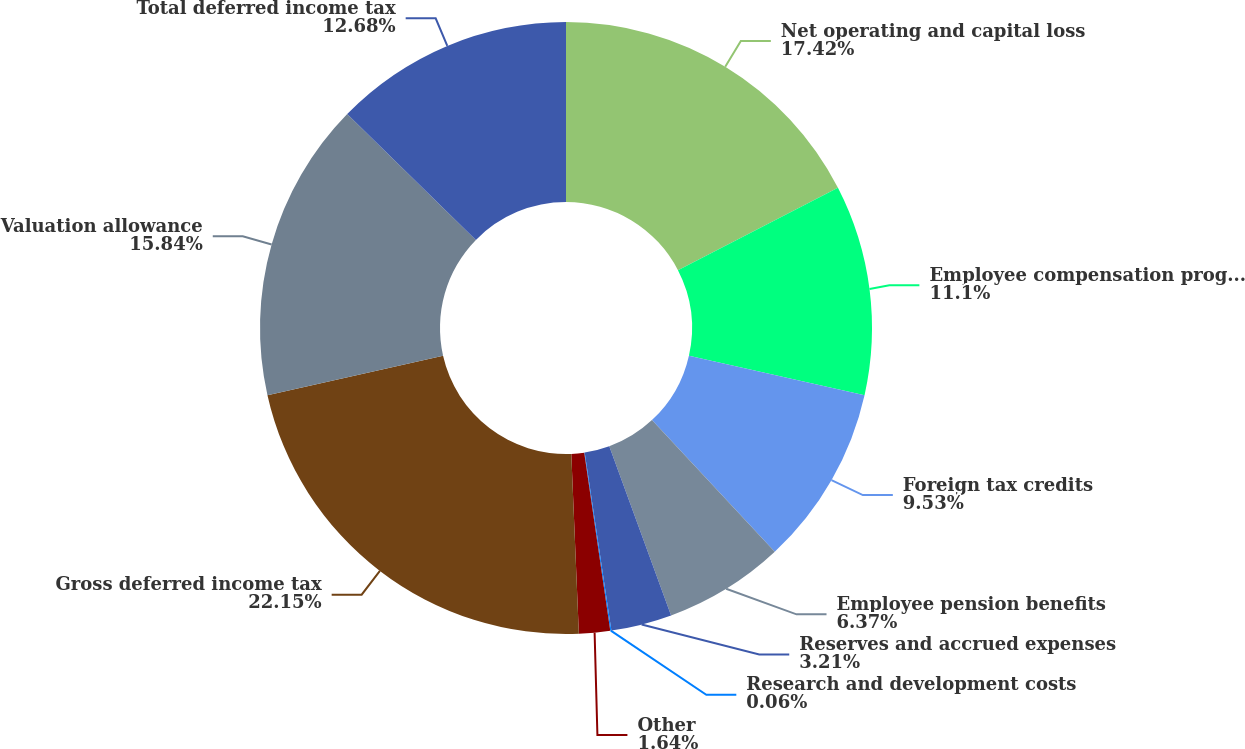Convert chart. <chart><loc_0><loc_0><loc_500><loc_500><pie_chart><fcel>Net operating and capital loss<fcel>Employee compensation programs<fcel>Foreign tax credits<fcel>Employee pension benefits<fcel>Reserves and accrued expenses<fcel>Research and development costs<fcel>Other<fcel>Gross deferred income tax<fcel>Valuation allowance<fcel>Total deferred income tax<nl><fcel>17.42%<fcel>11.1%<fcel>9.53%<fcel>6.37%<fcel>3.21%<fcel>0.06%<fcel>1.64%<fcel>22.15%<fcel>15.84%<fcel>12.68%<nl></chart> 